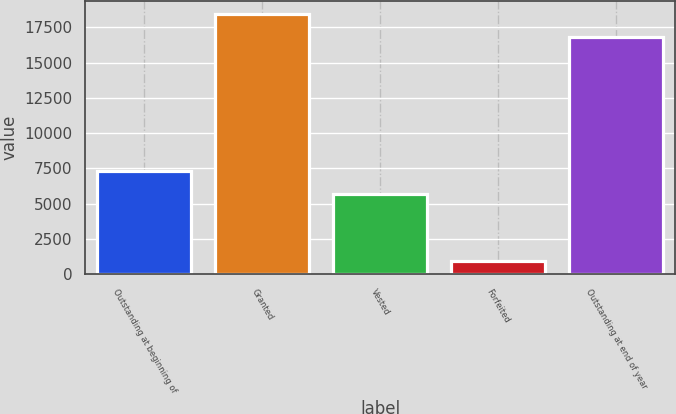Convert chart. <chart><loc_0><loc_0><loc_500><loc_500><bar_chart><fcel>Outstanding at beginning of<fcel>Granted<fcel>Vested<fcel>Forfeited<fcel>Outstanding at end of year<nl><fcel>7322.5<fcel>18475.5<fcel>5660<fcel>944<fcel>16813<nl></chart> 